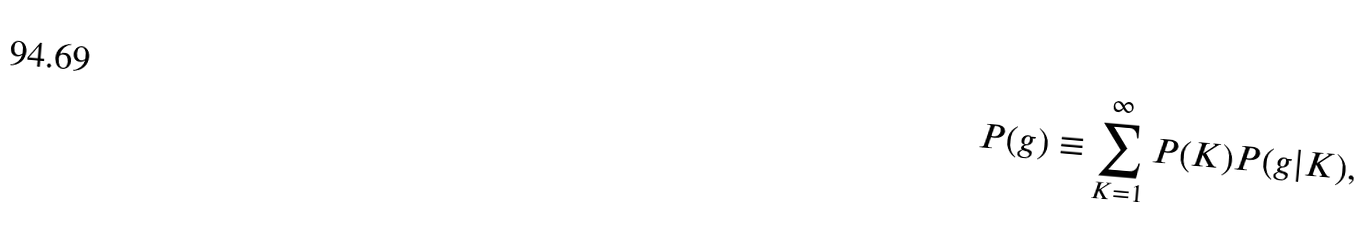Convert formula to latex. <formula><loc_0><loc_0><loc_500><loc_500>P ( g ) \equiv \sum _ { K = 1 } ^ { \infty } P ( K ) P ( g | K ) ,</formula> 